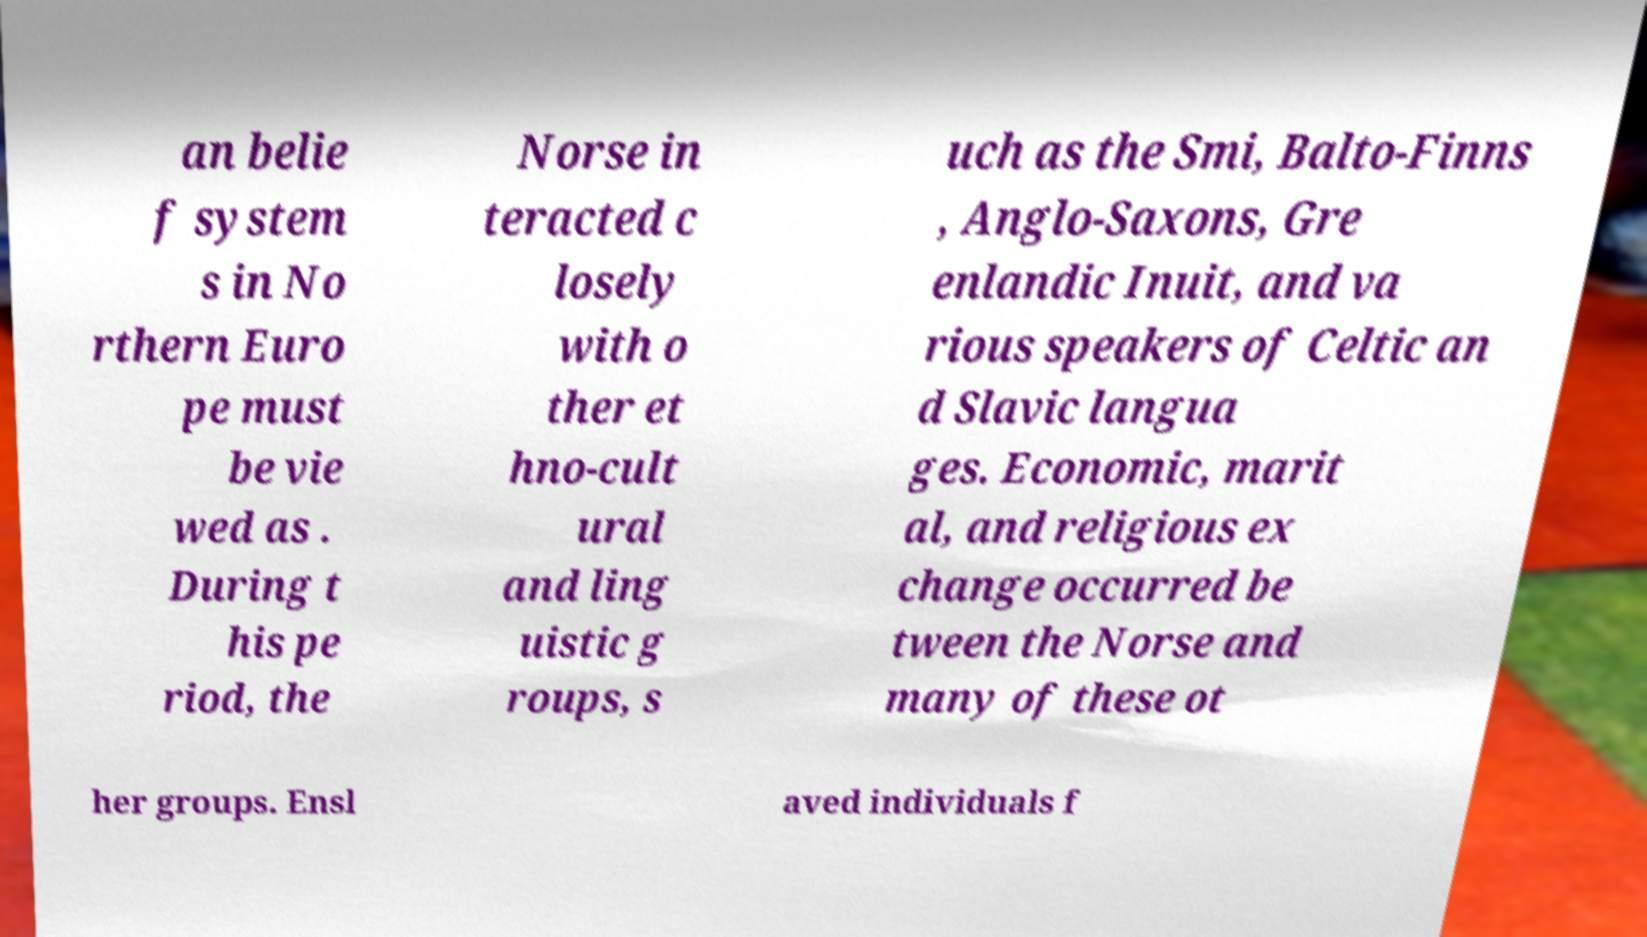Could you assist in decoding the text presented in this image and type it out clearly? an belie f system s in No rthern Euro pe must be vie wed as . During t his pe riod, the Norse in teracted c losely with o ther et hno-cult ural and ling uistic g roups, s uch as the Smi, Balto-Finns , Anglo-Saxons, Gre enlandic Inuit, and va rious speakers of Celtic an d Slavic langua ges. Economic, marit al, and religious ex change occurred be tween the Norse and many of these ot her groups. Ensl aved individuals f 